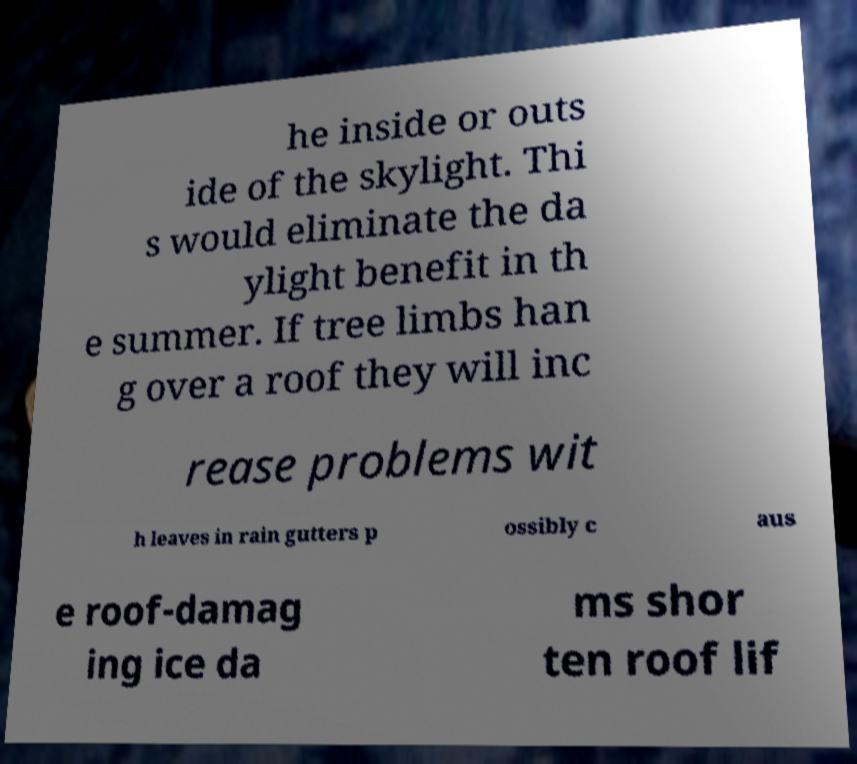Please identify and transcribe the text found in this image. he inside or outs ide of the skylight. Thi s would eliminate the da ylight benefit in th e summer. If tree limbs han g over a roof they will inc rease problems wit h leaves in rain gutters p ossibly c aus e roof-damag ing ice da ms shor ten roof lif 